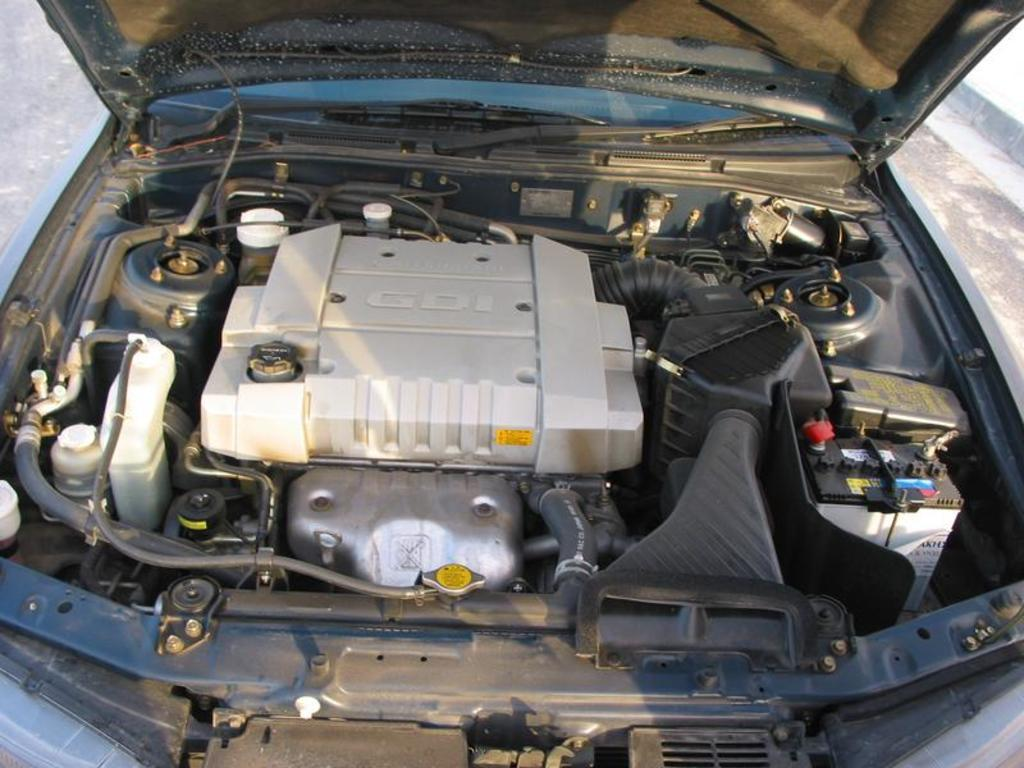What part of a car can be seen in the image? The front part of a car is visible in the image. What is the position of the bonnet in the image? The bonnet of the car is open in the image. What can be seen when the bonnet is open? The engine is visible in the image. What specific item related to the car's electrical system is present in the image? A battery is present in the image. What other items related to the car's engine can be seen in the image? Other items related to the car's engine are visible in the image. What type of suit is the car wearing in the image? Cars do not wear suits; the question is not applicable to the image. 